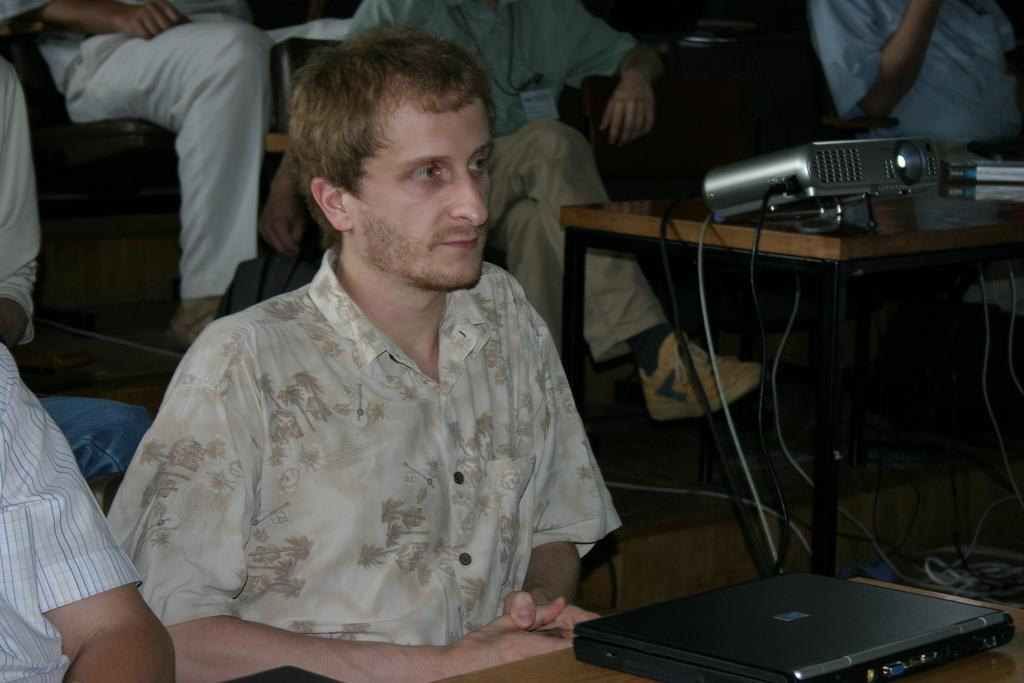What are the people in the image doing? There is a group of people sitting on chairs in the image. What objects can be seen on the table in the image? There is a device, a book, and a laptop on the table in the image. How many eggs are visible on the table in the image? There are no eggs visible on the table in the image. What type of dirt can be seen on the floor in the image? There is no dirt visible on the floor in the image. 